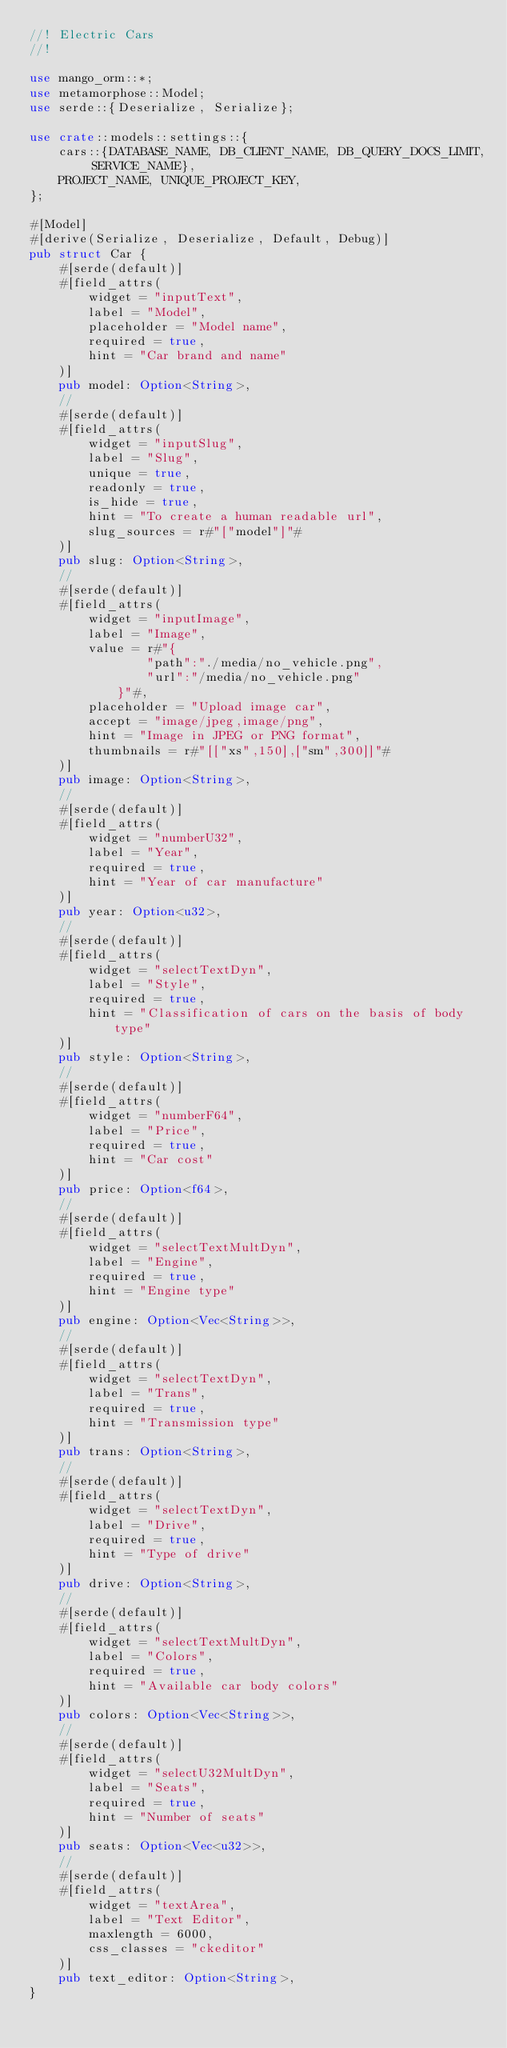<code> <loc_0><loc_0><loc_500><loc_500><_Rust_>//! Electric Cars
//!

use mango_orm::*;
use metamorphose::Model;
use serde::{Deserialize, Serialize};

use crate::models::settings::{
    cars::{DATABASE_NAME, DB_CLIENT_NAME, DB_QUERY_DOCS_LIMIT, SERVICE_NAME},
    PROJECT_NAME, UNIQUE_PROJECT_KEY,
};

#[Model]
#[derive(Serialize, Deserialize, Default, Debug)]
pub struct Car {
    #[serde(default)]
    #[field_attrs(
        widget = "inputText",
        label = "Model",
        placeholder = "Model name",
        required = true,
        hint = "Car brand and name"
    )]
    pub model: Option<String>,
    //
    #[serde(default)]
    #[field_attrs(
        widget = "inputSlug",
        label = "Slug",
        unique = true,
        readonly = true,
        is_hide = true,
        hint = "To create a human readable url",
        slug_sources = r#"["model"]"#
    )]
    pub slug: Option<String>,
    //
    #[serde(default)]
    #[field_attrs(
        widget = "inputImage",
        label = "Image",
        value = r#"{
                "path":"./media/no_vehicle.png",
                "url":"/media/no_vehicle.png"
            }"#,
        placeholder = "Upload image car",
        accept = "image/jpeg,image/png",
        hint = "Image in JPEG or PNG format",
        thumbnails = r#"[["xs",150],["sm",300]]"#
    )]
    pub image: Option<String>,
    //
    #[serde(default)]
    #[field_attrs(
        widget = "numberU32",
        label = "Year",
        required = true,
        hint = "Year of car manufacture"
    )]
    pub year: Option<u32>,
    //
    #[serde(default)]
    #[field_attrs(
        widget = "selectTextDyn",
        label = "Style",
        required = true,
        hint = "Classification of cars on the basis of body type"
    )]
    pub style: Option<String>,
    //
    #[serde(default)]
    #[field_attrs(
        widget = "numberF64",
        label = "Price",
        required = true,
        hint = "Car cost"
    )]
    pub price: Option<f64>,
    //
    #[serde(default)]
    #[field_attrs(
        widget = "selectTextMultDyn",
        label = "Engine",
        required = true,
        hint = "Engine type"
    )]
    pub engine: Option<Vec<String>>,
    //
    #[serde(default)]
    #[field_attrs(
        widget = "selectTextDyn",
        label = "Trans",
        required = true,
        hint = "Transmission type"
    )]
    pub trans: Option<String>,
    //
    #[serde(default)]
    #[field_attrs(
        widget = "selectTextDyn",
        label = "Drive",
        required = true,
        hint = "Type of drive"
    )]
    pub drive: Option<String>,
    //
    #[serde(default)]
    #[field_attrs(
        widget = "selectTextMultDyn",
        label = "Colors",
        required = true,
        hint = "Available car body colors"
    )]
    pub colors: Option<Vec<String>>,
    //
    #[serde(default)]
    #[field_attrs(
        widget = "selectU32MultDyn",
        label = "Seats",
        required = true,
        hint = "Number of seats"
    )]
    pub seats: Option<Vec<u32>>,
    //
    #[serde(default)]
    #[field_attrs(
        widget = "textArea",
        label = "Text Editor",
        maxlength = 6000,
        css_classes = "ckeditor"
    )]
    pub text_editor: Option<String>,
}
</code> 